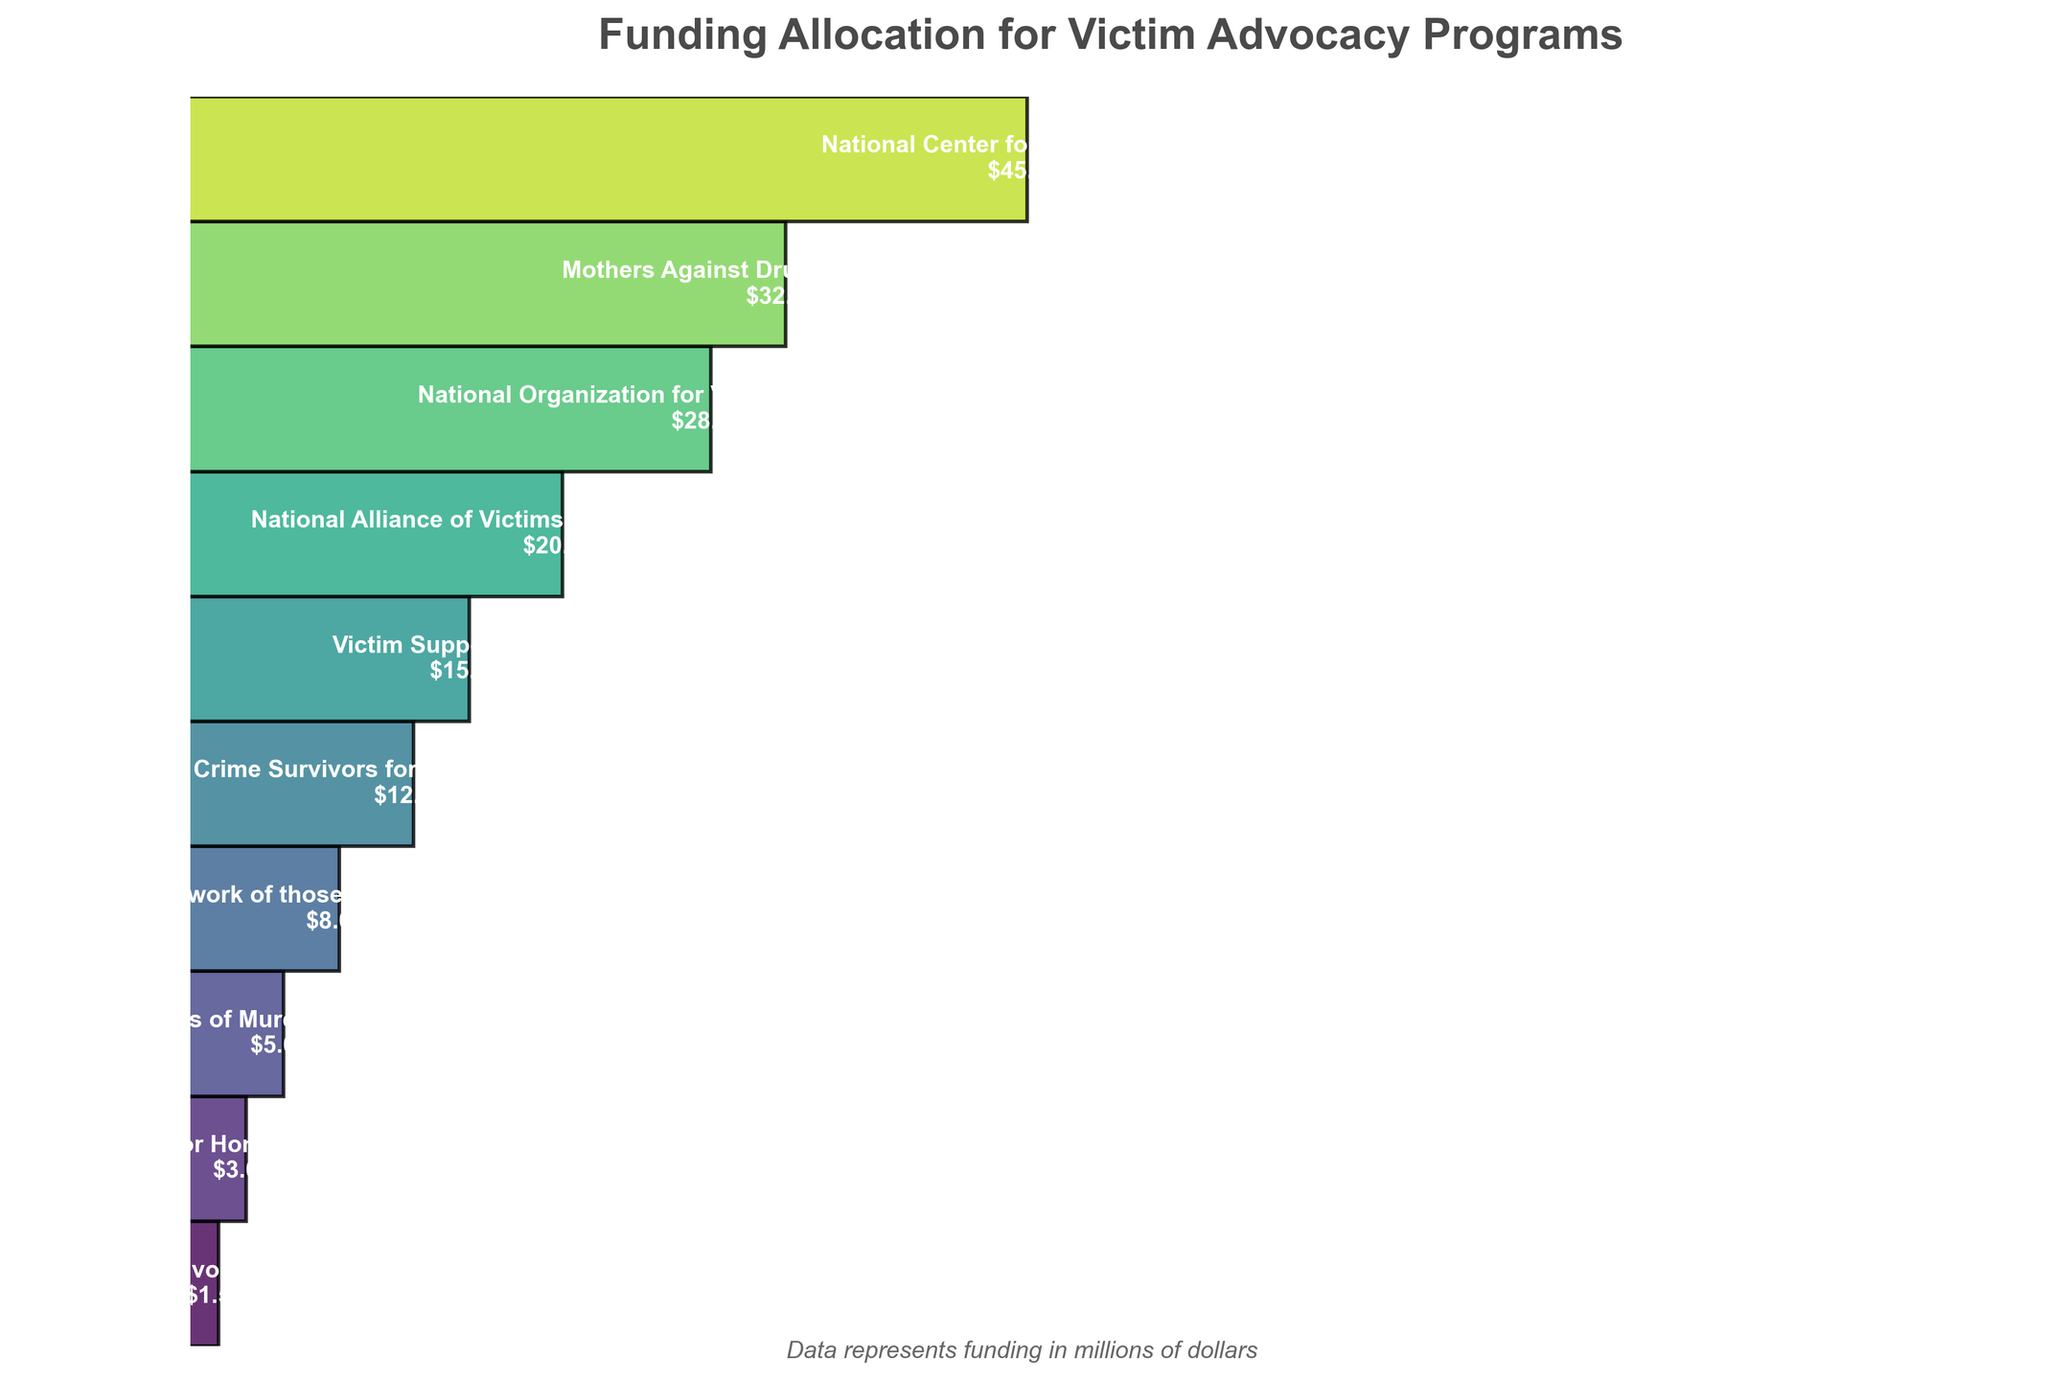What is the title of the figure? The title is clearly displayed at the top of the figure. It provides an overview of what the chart is about.
Answer: Funding Allocation for Victim Advocacy Programs How much funding is allocated to the National Center for Victims of Crime? The funding amount is shown within the segment corresponding to the National Center for Victims of Crime.
Answer: $45M Which category has the least amount of funding? By looking at the smallest segment at the bottom of the funnel chart, it can be seen which category has the least funding.
Answer: Homicide Survivors Support Group What is the combined funding for Mothers Against Drunk Driving (MADD) and Victim Support Services? Add the funding amounts of MADD ($32M) and Victim Support Services ($15M).
Answer: $47M What’s the difference in funding between Crime Survivors for Safety and Justice and Survivors Network of those Abused by Priests (SNAP)? Subtract the funding amount of SNAP ($8M) from the funding amount of Crime Survivors for Safety and Justice ($12M).
Answer: $4M How many categories are included in the figure? Count the number of distinct segments (categories) present in the funnel chart from top to bottom.
Answer: 10 Which organization receives more funding: National Organization for Victim Assistance (NOVA) or National Alliance of Victims' Rights Attorneys (NAVRA)? Compare the segments for NOVA ($28M) and NAVRA ($20M); the larger segment represents the organization with more funding.
Answer: National Organization for Victim Assistance (NOVA) What is the average funding amount across all categories? Add the funding amounts of all categories together and divide by the total number of categories (10). The calculation is: (45 + 32 + 28 + 20 + 15 + 12 + 8 + 5 + 3 + 1.5) / 10
Answer: $16.95M How much more funding does Parents of Murdered Children receive compared to Justice for Homicide Victims? Subtract the funding amount of Justice for Homicide Victims ($3M) from Parents of Murdered Children ($5M).
Answer: $2M 